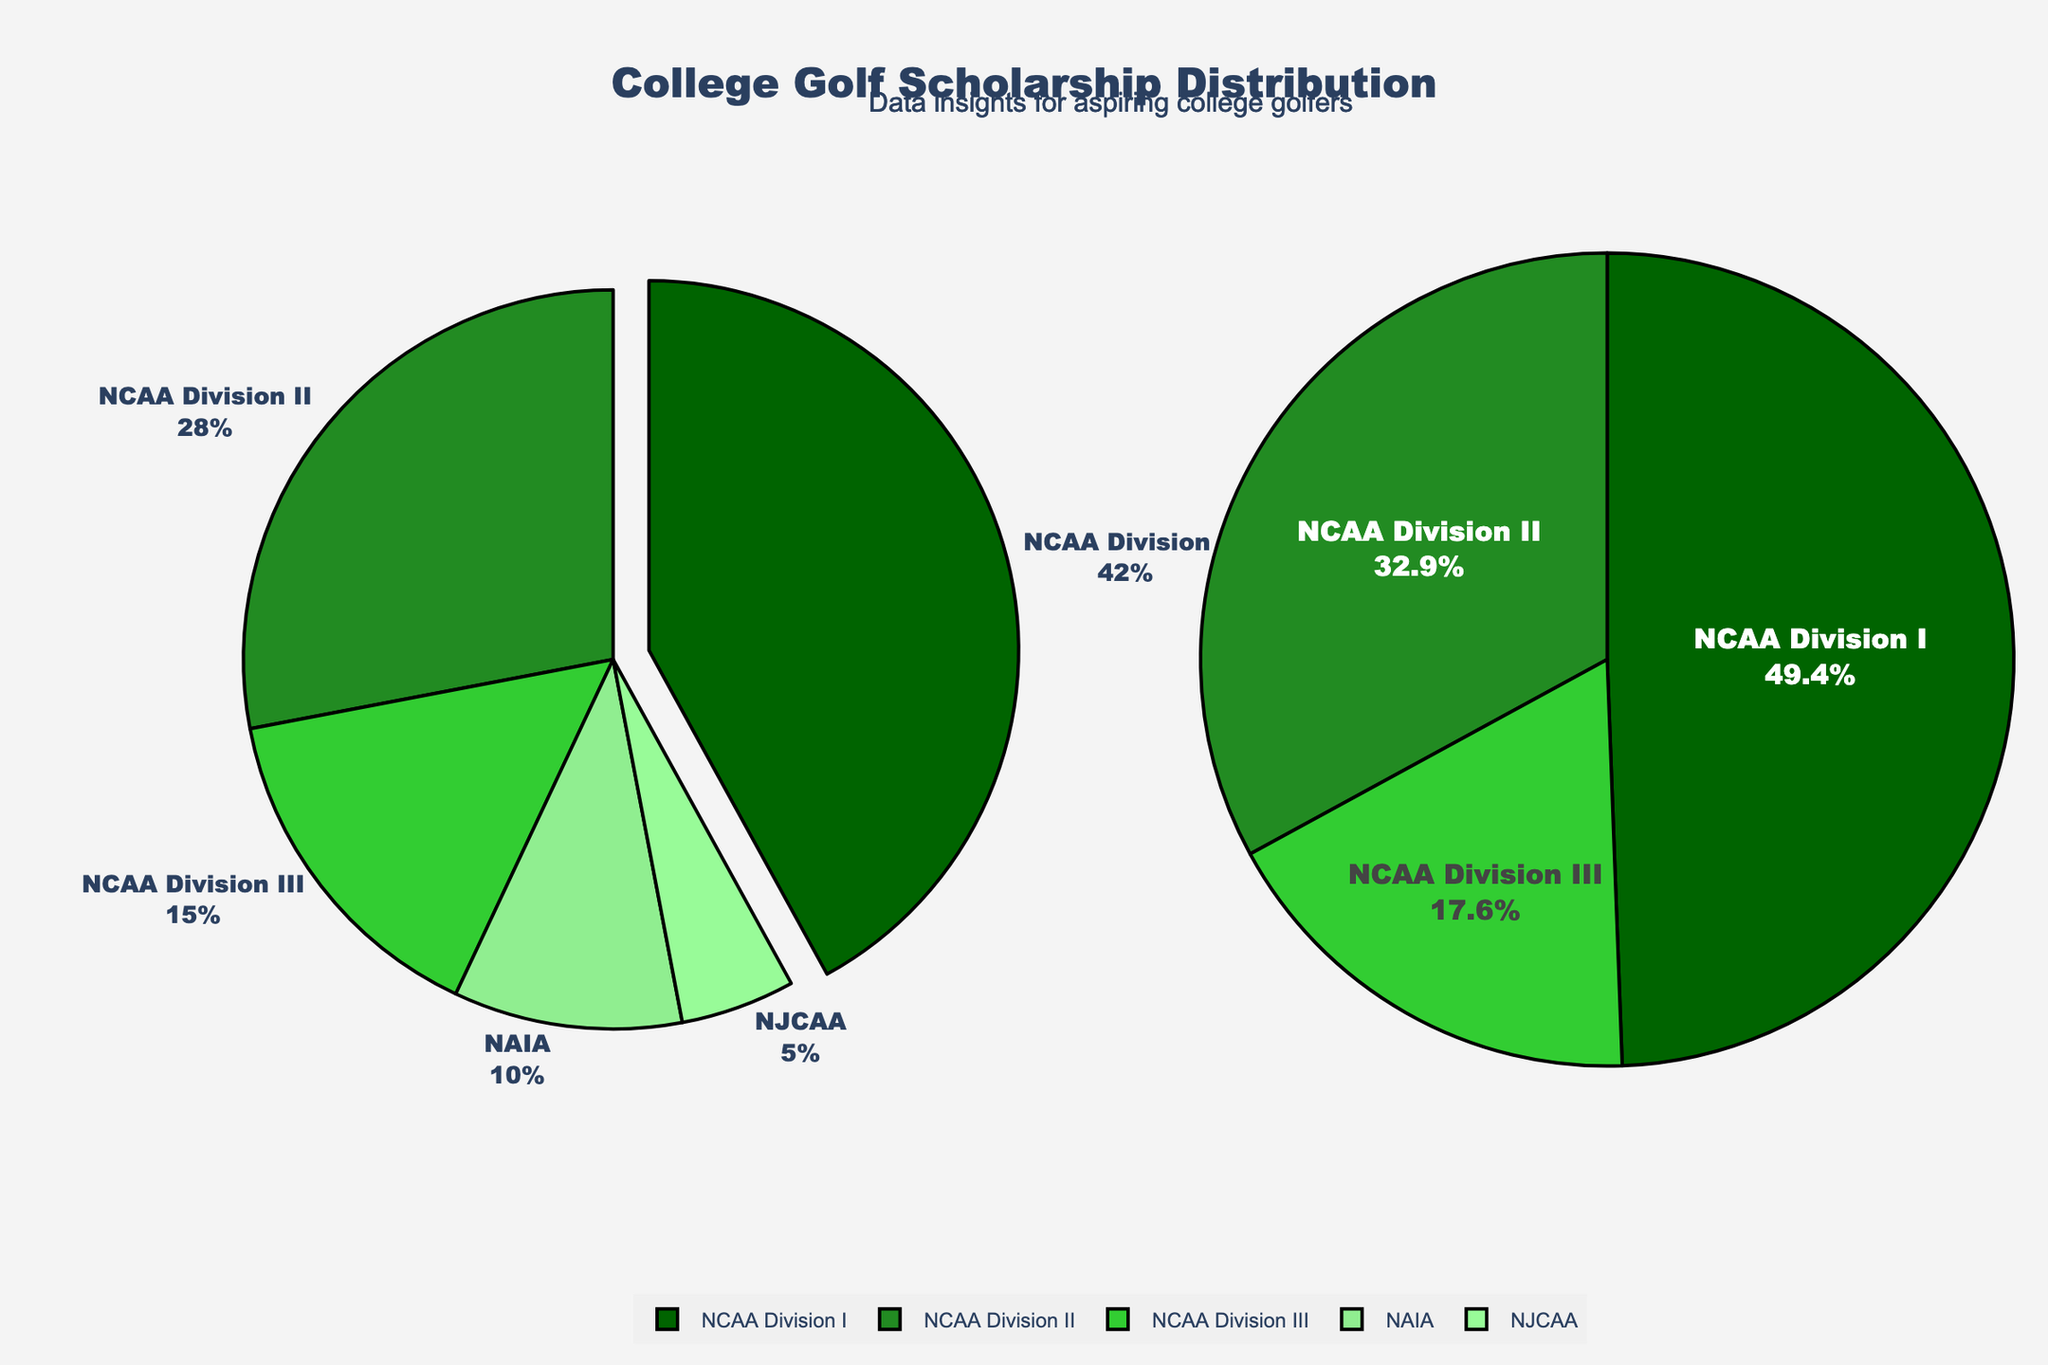Which division has the highest percentage of college golf scholarships? Refer to the pie chart. NCAA Division I has the highest percentage slice with 42%.
Answer: NCAA Division I Which division awards the least percentage of scholarships? Look at the pie chart and identify the smallest slice. NJCAA has the smallest slice with 5%.
Answer: NJCAA How much more percentage does NCAA Division I award compared to NAIA? NCAA Division I awards 42%, and NAIA awards 10%. Subtract the smaller percentage from the larger one: 42% - 10% = 32%.
Answer: 32% What is the combined percentage of scholarships awarded by NCAA Division II and NCAA Division III? Add the percentages of NCAA Division II (28%) and NCAA Division III (15%) together: 28% + 15% = 43%.
Answer: 43% Which three divisions have the highest scholarship percentages in descending order? Refer to the pie chart and identify the three largest slices. They are NCAA Division I (42%), NCAA Division II (28%), and NCAA Division III (15%).
Answer: NCAA Division I, NCAA Division II, NCAA Division III What is the percentage difference between the division with the highest scholarships and the division with the lowest scholarships? The highest percentage is 42% (NCAA Division I), and the lowest is 5% (NJCAA). Subtract the smallest percentage from the largest one: 42% - 5% = 37%.
Answer: 37% What is the average percentage of scholarships awarded by NAIA and NJCAA? Add the percentages of NAIA (10%) and NJCAA (5%) and divide by 2: (10% + 5%) / 2 = 7.5%.
Answer: 7.5% How many more percentage points does NCAA Division I award compared to the top three divisions' average percentage? First, find the average percentage of the top three divisions: (NCAA Division I (42%) + NCAA Division II (28%) + NCAA Division III (15%)) / 3. The average is (42 + 28 + 15) / 3 = 28.33%. Then, subtract this average from NCAA Division I's percentage: 42% - 28.33% ≈ 13.67%.
Answer: 13.67% Which slice of the pie charts uses a darker green color? The labels in the figure indicate which division each slice represents. The pie slices are of different green shades, with NCAA Division I likely using the darkest green.
Answer: NCAA Division I 